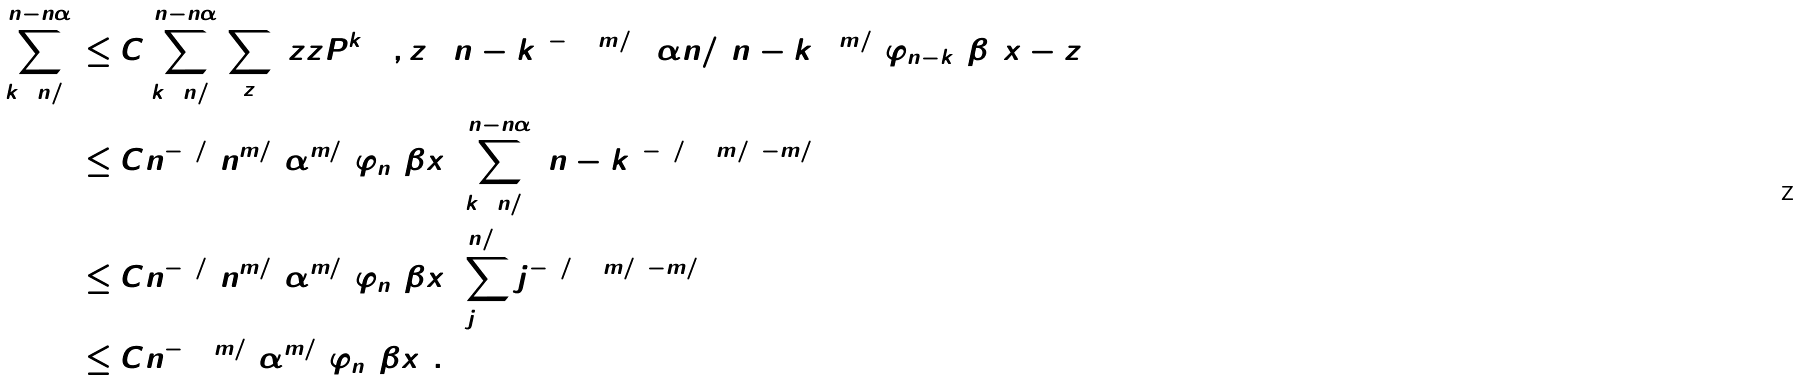<formula> <loc_0><loc_0><loc_500><loc_500>\sum _ { k = n / 2 } ^ { n - n \alpha } & \leq C \sum _ { k = n / 2 } ^ { n - n \alpha } \sum _ { z } \ z z { P } ^ { k } ( 0 , z ) ( n - k ) ^ { - 2 + m / 2 } ( \alpha n / ( n - k ) ) ^ { m / 5 } \varphi _ { n - k } ( \beta ( x - z ) ) \\ & \leq C n ^ { - 1 / 2 } n ^ { m / 5 } \alpha ^ { m / 5 } \varphi _ { n } ( \beta x ) \sum _ { k = n / 2 } ^ { n - n \alpha } ( n - k ) ^ { - 3 / 2 + m / 2 - m / 5 } \\ & \leq C n ^ { - 1 / 2 } n ^ { m / 5 } \alpha ^ { m / 5 } \varphi _ { n } ( \beta x ) \sum _ { j = 1 } ^ { n / 2 } j ^ { - 3 / 2 + m / 2 - m / 5 } \\ & \leq C n ^ { - 1 + m / 2 } \alpha ^ { m / 5 } \varphi _ { n } ( \beta x ) .</formula> 